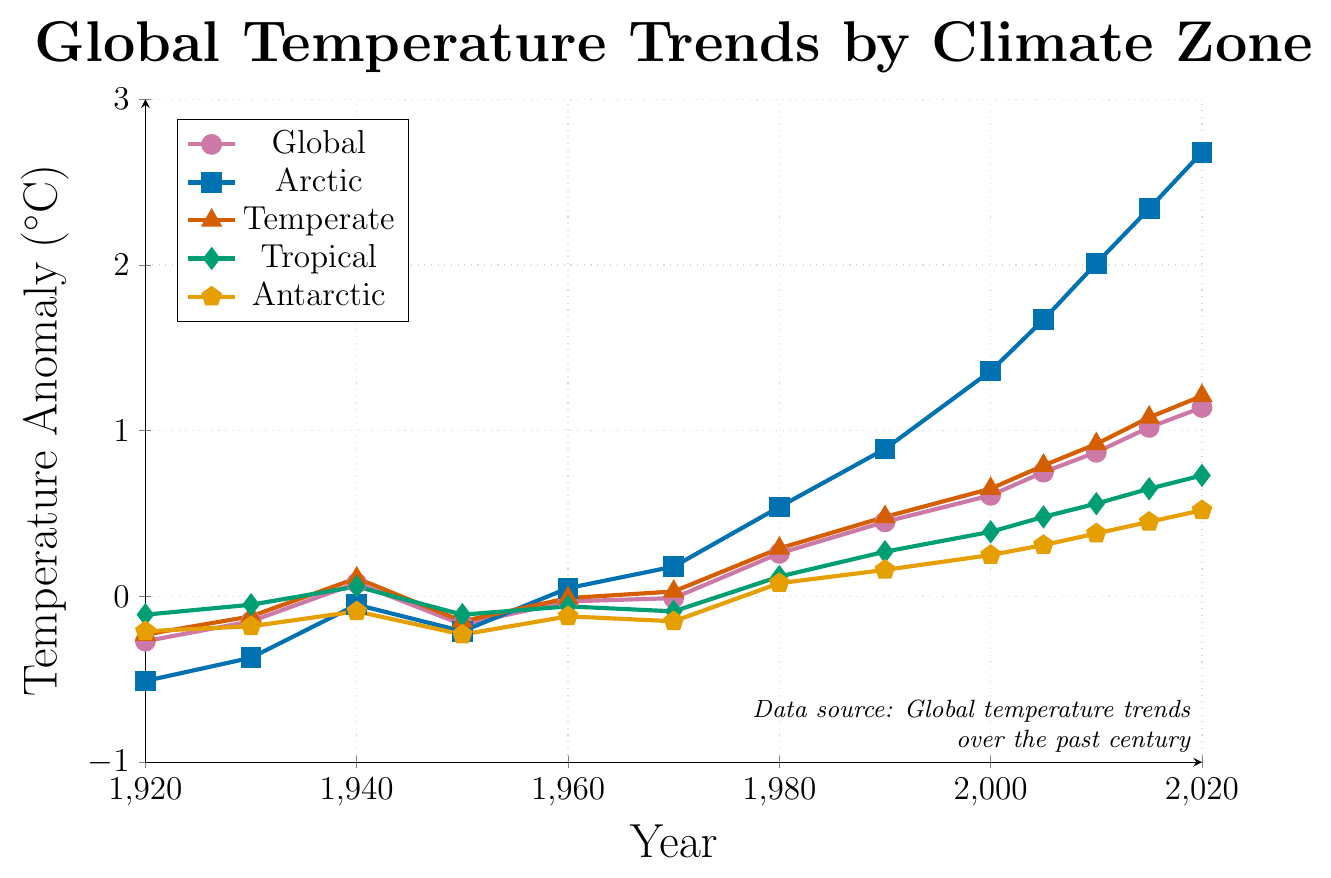Which climate zone shows the most significant increase in temperature anomalies from 1920 to 2020? To determine the climate zone with the most significant increase, compare the temperature anomaly values from 1920 and 2020 for each zone. The Arctic shows an increase from -0.51°C to 2.68°C, which is the largest among all climate zones.
Answer: Arctic Do all regions show positive temperature anomalies by 2020? Check the temperature anomaly values for 2020 for all regions: Global (1.14°C), Arctic (2.68°C), Temperate (1.21°C), Tropical (0.73°C), and Antarctic (0.52°C). All values are above zero, indicating positive anomalies.
Answer: Yes What is the difference in temperature anomaly between the Arctic and the Antarctic in 2020? Subtract the Antarctic value (0.52°C) from the Arctic value (2.68°C) in 2020 to find the difference: 2.68 - 0.52 = 2.16.
Answer: 2.16°C In which decade did the Arctic temperature anomaly exceed the global temperature anomaly for the first time? Compare the Arctic and global temperature anomalies decade by decade. In 1960, Arctic (-0.05°C) is less than Global (-0.03°C); in 1970, Arctic (0.18°C) exceeds Global (-0.01°C) for the first time.
Answer: 1970s What is the average temperature anomaly for the Global data in the 2000s (2000, 2005, 2010)? Add the values for 2000 (0.61°C), 2005 (0.75°C), and 2010 (0.87°C) and divide by 3: (0.61 + 0.75 + 0.87) / 3 = 2.23 / 3 ≈ 0.74.
Answer: 0.74°C How did the Tropical temperature anomaly change from 1920 to 1950? Subtract the 1920 value (-0.11°C) from the 1950 value (-0.11°C): -0.11 - (-0.11) = 0. The anomaly did not change.
Answer: No change 